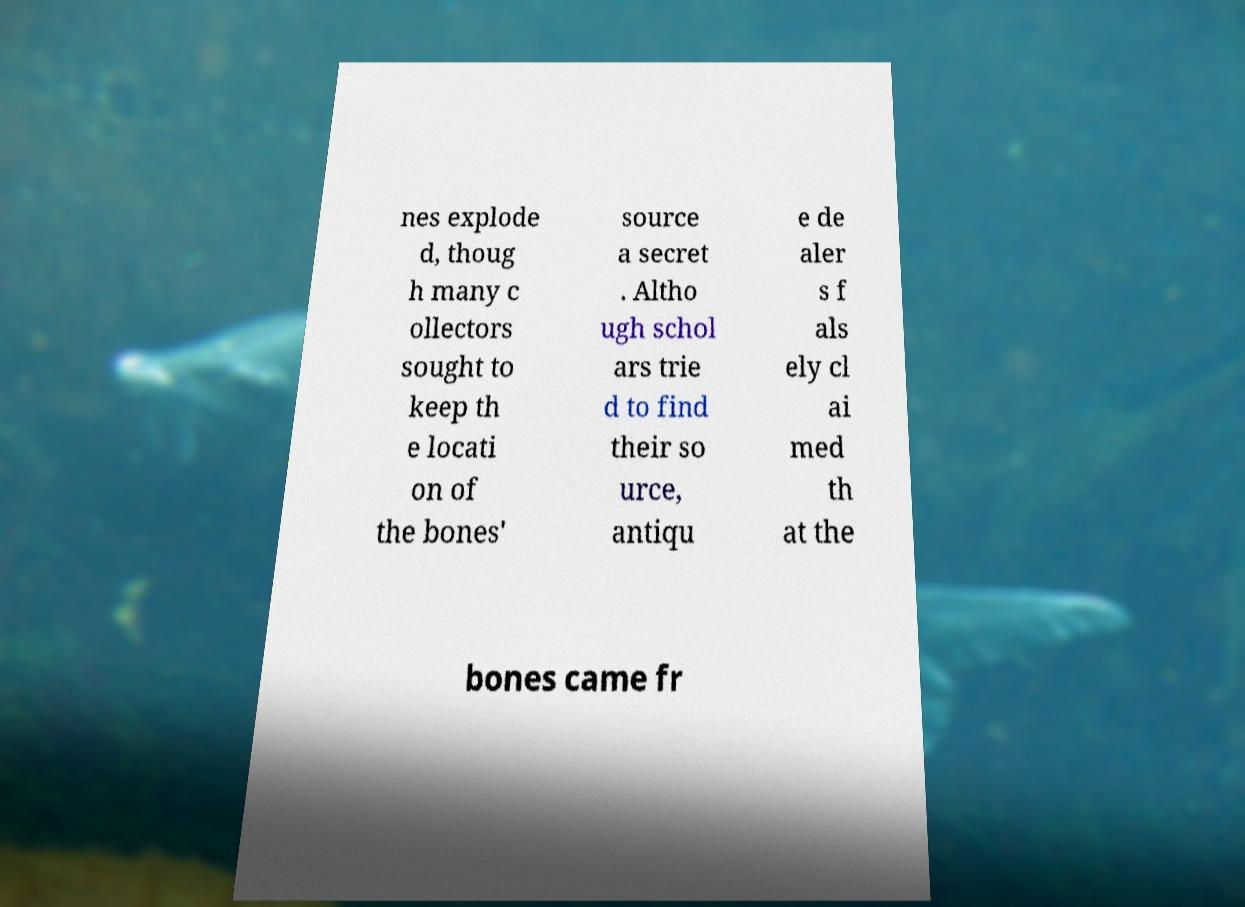For documentation purposes, I need the text within this image transcribed. Could you provide that? nes explode d, thoug h many c ollectors sought to keep th e locati on of the bones' source a secret . Altho ugh schol ars trie d to find their so urce, antiqu e de aler s f als ely cl ai med th at the bones came fr 